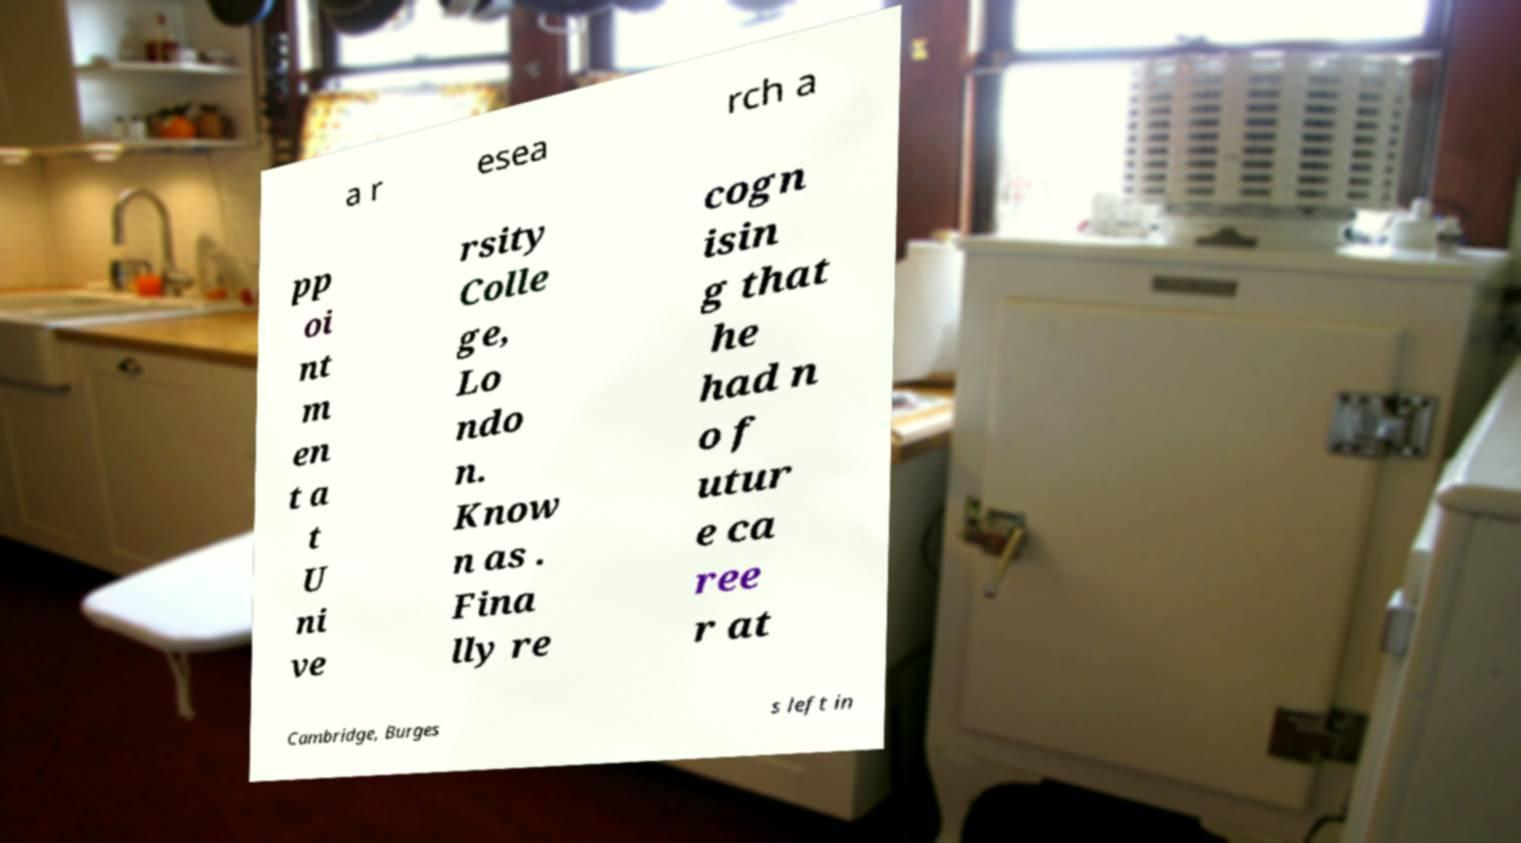Please identify and transcribe the text found in this image. a r esea rch a pp oi nt m en t a t U ni ve rsity Colle ge, Lo ndo n. Know n as . Fina lly re cogn isin g that he had n o f utur e ca ree r at Cambridge, Burges s left in 